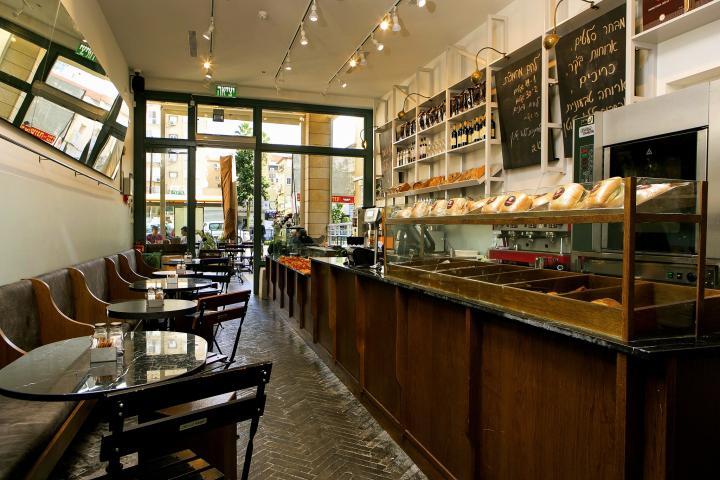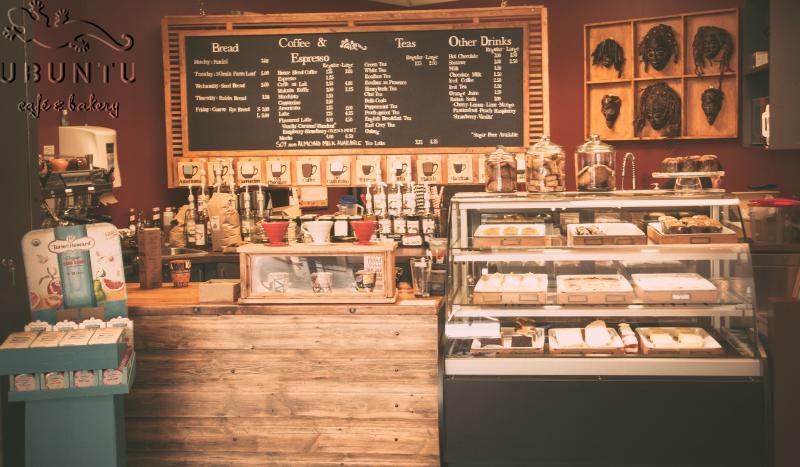The first image is the image on the left, the second image is the image on the right. For the images displayed, is the sentence "In each image, a bakery cafe has its menu posted on one or more black boards, but table seating is seen in only one image." factually correct? Answer yes or no. Yes. The first image is the image on the left, the second image is the image on the right. Examine the images to the left and right. Is the description "At least one image shows a bakery interior with rounded tables in front of bench seats along the wall, facing display cases with blackboards hung above them." accurate? Answer yes or no. Yes. 